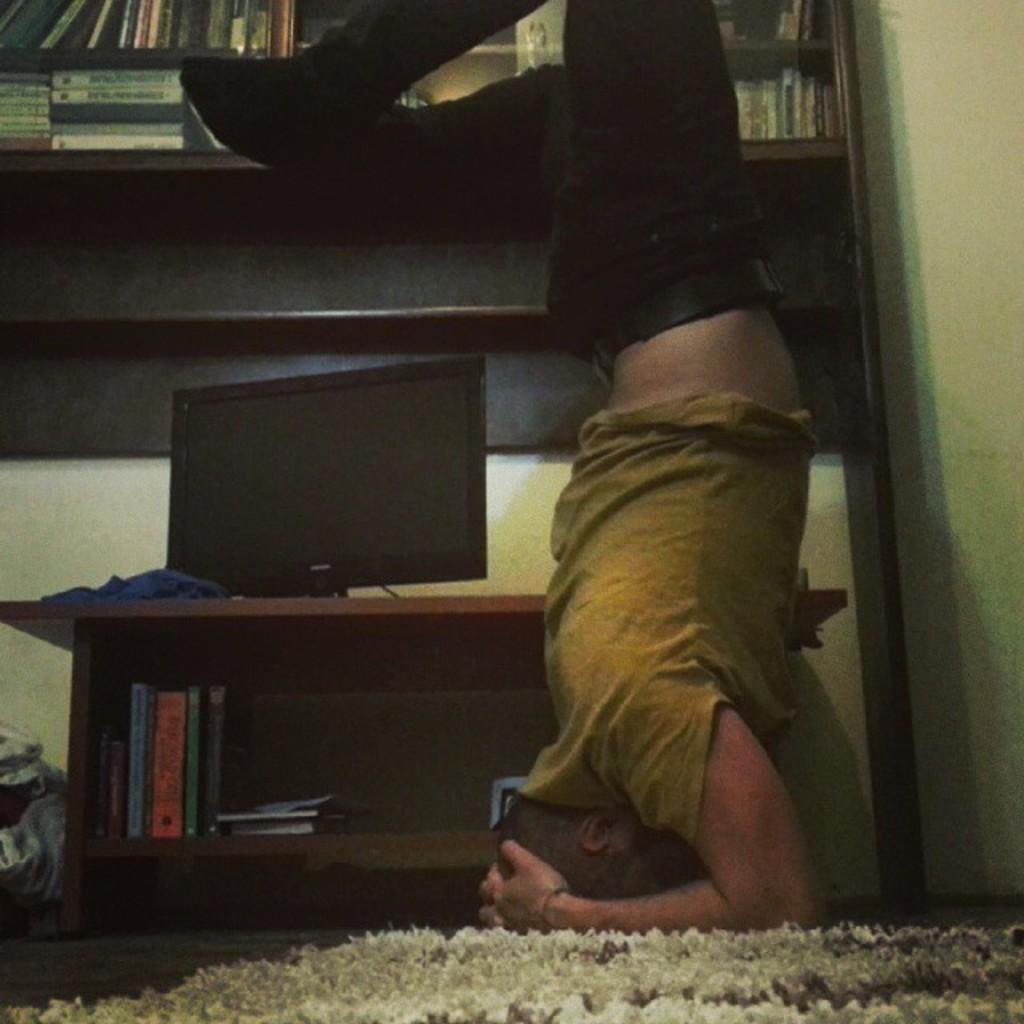How would you summarize this image in a sentence or two? In this image I can see a person. I can see a computer on the table. In the background, I can see some books in the shelf. 